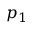<formula> <loc_0><loc_0><loc_500><loc_500>p _ { 1 }</formula> 